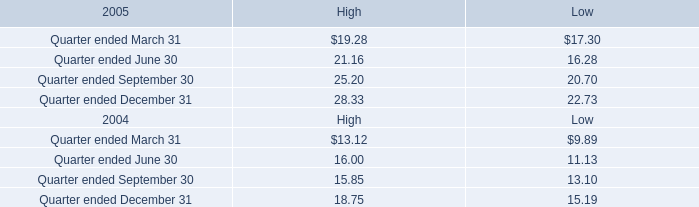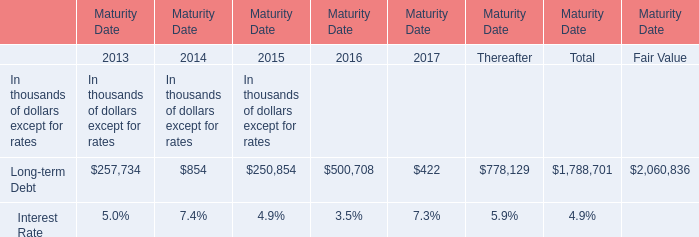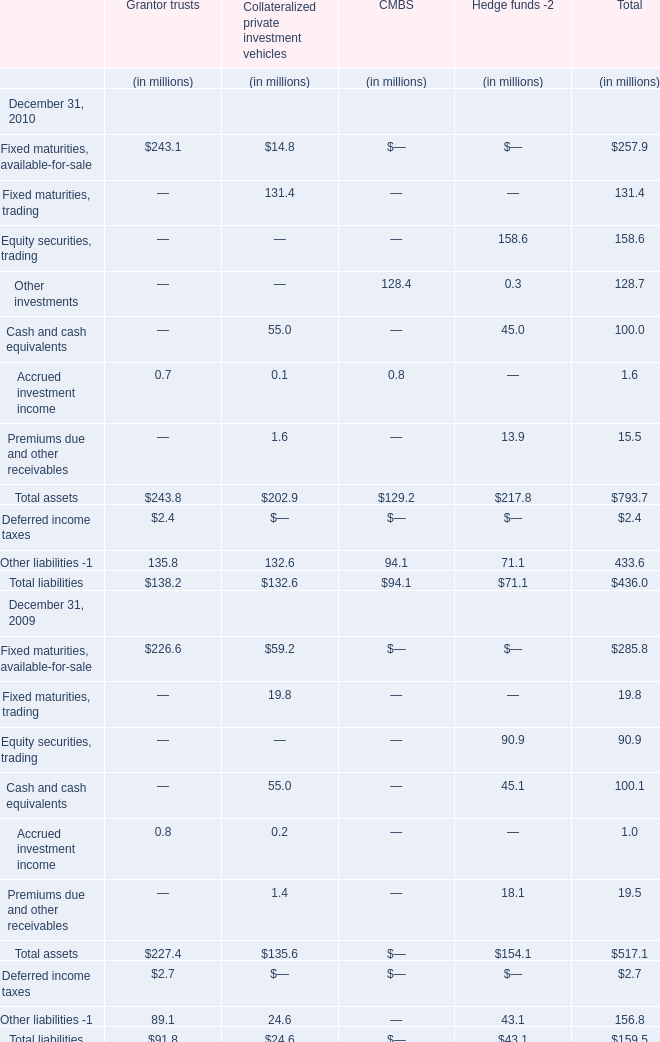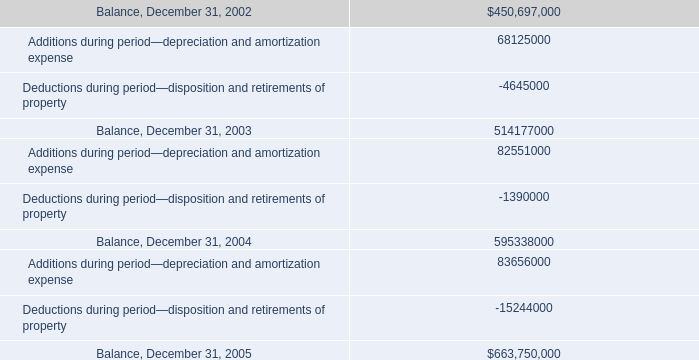In what year is Fixed maturities, trading in total greater than 100? 
Answer: 2010. 